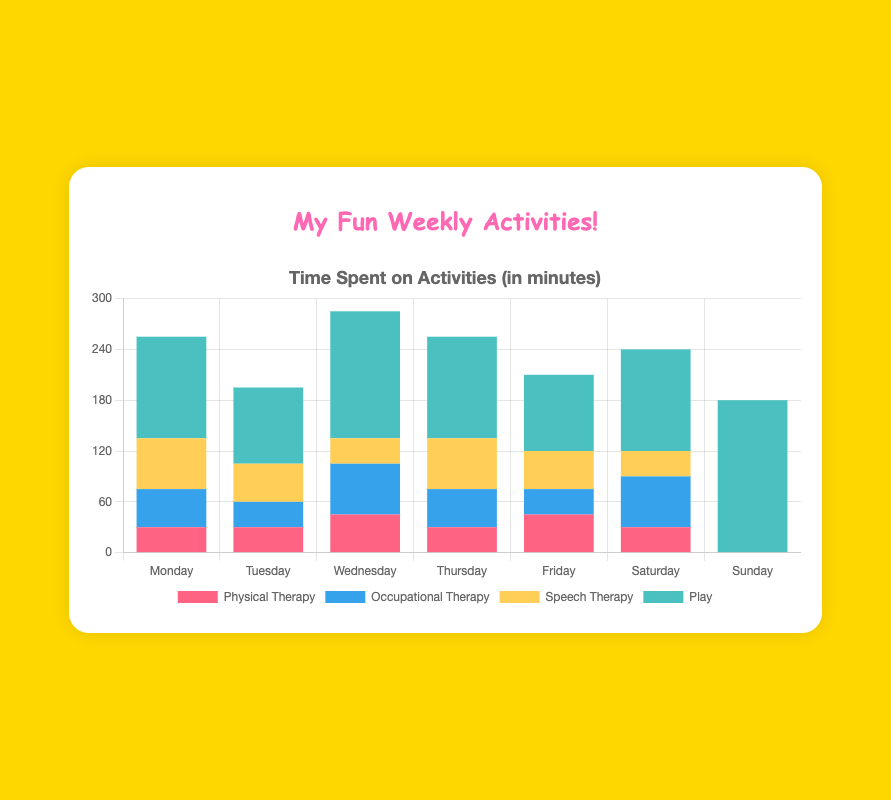Which day has the most playtime? Look at the heights of the sections labeled "Play" for each bar. Sunday has the tallest segment, indicating the most playtime.
Answer: Sunday On which day did I spend the least amount of time on physical therapy? Look at the bottom segments of each bar labeled "Physical Therapy". On Sunday, there is no red segment, indicating 0 minutes spent on physical therapy.
Answer: Sunday How many total minutes did I spend on activities on Friday? Add up the heights of all segments in Friday's bar: 45 (Physical Therapy) + 30 (Occupational Therapy) + 45 (Speech Therapy) + 90 (Play) = 210 minutes.
Answer: 210 minutes Which therapy did I spend the most time on Wednesday? Compare the heights of the segments labeled "Physical Therapy", "Occupational Therapy", and "Speech Therapy" in Wednesday's bar. The "Occupational Therapy" segment is the tallest.
Answer: Occupational Therapy Which day has equal time spent on physical therapy and speech therapy? Compare the segments for "Physical Therapy" and "Speech Therapy" for each bar. On Saturday, both segments are equal in height, indicating equal time spent.
Answer: Saturday Did I spend more time playing on Thursday or Tuesday? Compare the heights of the "Play" segments for Thursday and Tuesday. Thursday's "Play" segment is taller, indicating more playtime.
Answer: Thursday What is the average time spent on occupational therapy from Monday to Friday? Add the times for occupational therapy from Monday to Friday: 45 + 30 + 60 + 45 + 30 = 210. Divide by 5 days: 210 / 5 = 42.
Answer: 42 minutes How many more minutes did I spend on play on Sunday compared to Tuesday? Subtract the playtime on Tuesday from the playtime on Sunday: 180 - 90 = 90 minutes.
Answer: 90 minutes What is the total time spent on speech therapy on Tuesday and Thursday combined? Add the speech therapy times for Tuesday and Thursday: 45 + 60 = 105 minutes.
Answer: 105 minutes 